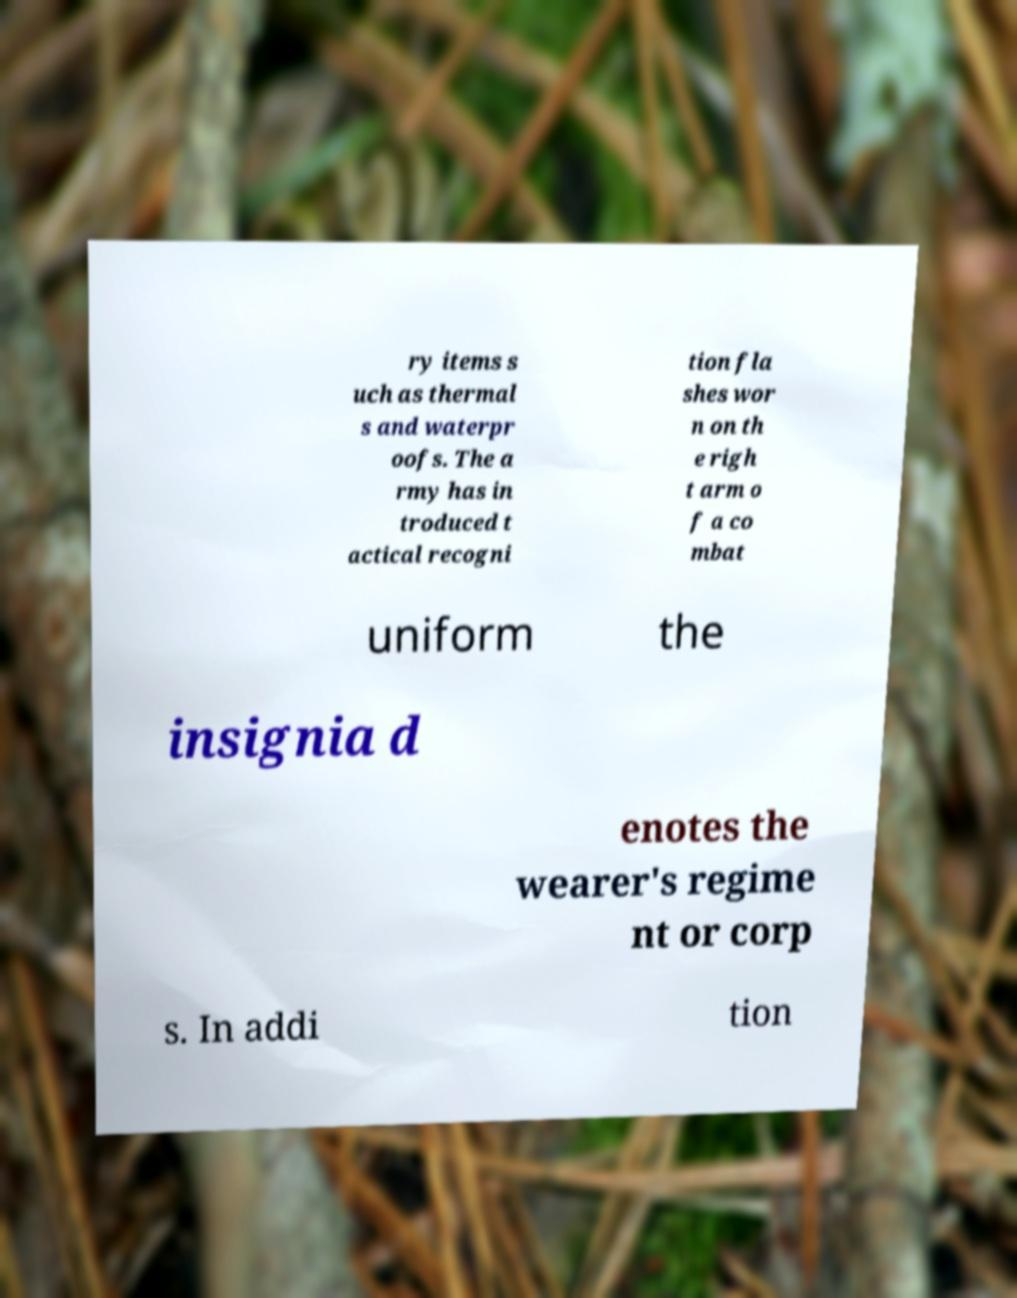Please identify and transcribe the text found in this image. ry items s uch as thermal s and waterpr oofs. The a rmy has in troduced t actical recogni tion fla shes wor n on th e righ t arm o f a co mbat uniform the insignia d enotes the wearer's regime nt or corp s. In addi tion 